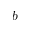<formula> <loc_0><loc_0><loc_500><loc_500>b</formula> 